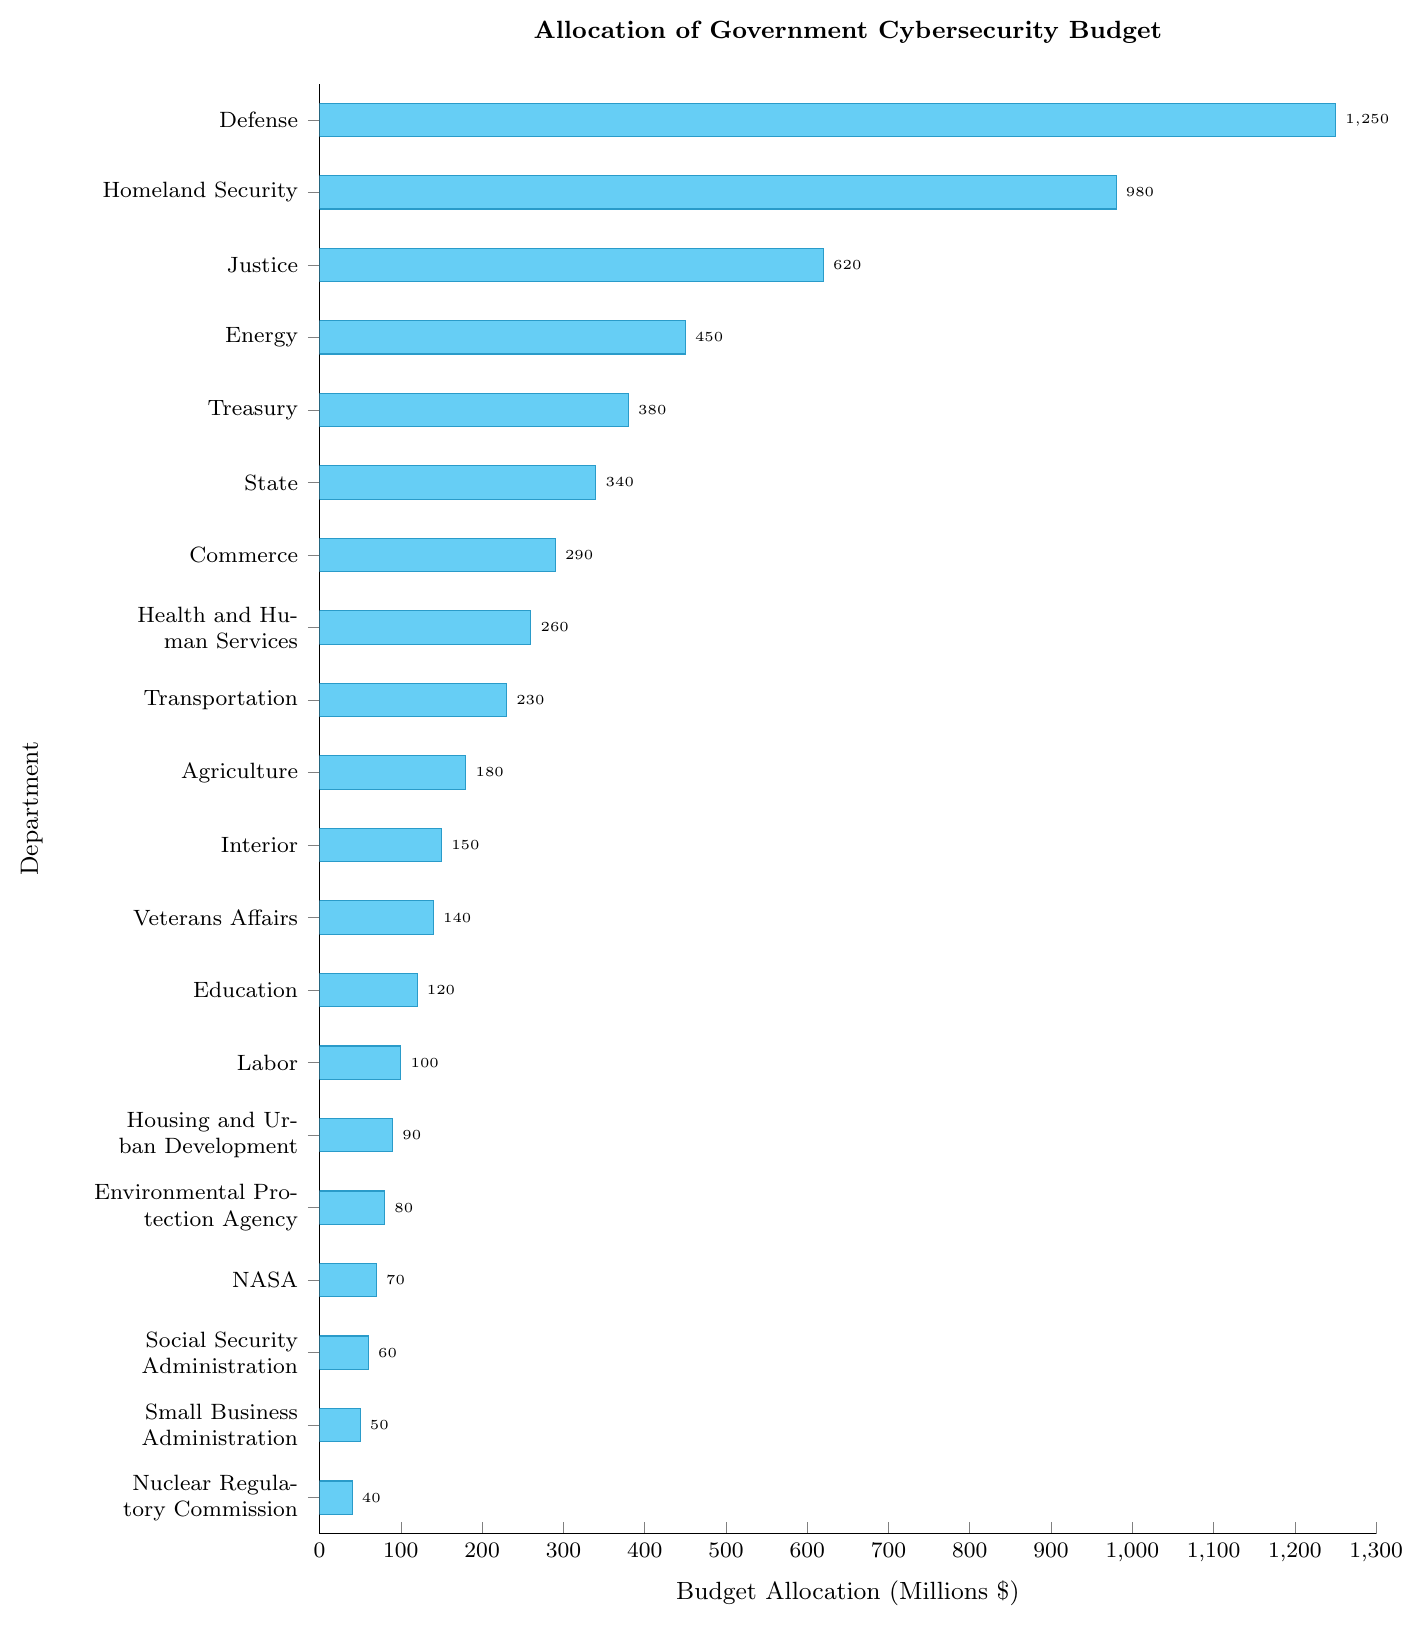Which department receives the highest cybersecurity budget? The bar representing the "Defense" department is the longest, indicating it has the highest budget allocation
Answer: Defense What is the budget allocation for the Department of Energy? The figure shows a bar next to the "Energy" label with a marker at the corresponding value on the x-axis, indicating the allocation
Answer: 450 million dollars How does the budget for Homeland Security compare to that of the Department of Defense? Both bars are visible, and the Homeland Security bar is shorter than the Defense bar, indicating a smaller budget
Answer: Homeland Security has a smaller budget What is the sum of the budget allocations for the Department of Justice and the Treasury? The Justice department has a bar of 620 million dollars and the Treasury has 380 million dollars; adding them together gives 620 + 380
Answer: 1000 million dollars Which departments have a budget allocation greater than 500 million dollars? Observing the figure, the departments with bars extending past the 500-million dollar mark are Defense, Homeland Security, and Justice
Answer: Defense, Homeland Security, Justice What is the difference in budget allocation between the Department of Veterans Affairs and the Department of Education? The Veterans Affairs bar is at 140 million dollars, and the Education department's bar is at 120 million dollars; subtracting 120 from 140 gives 140 - 120
Answer: 20 million dollars What is the average budget allocation for the departments of Commerce, Health and Human Services, and Transportation? The allocations are 290, 260, and 230 million dollars respectively. Summing these gives 290 + 260 + 230 = 780, and dividing by the number of departments (3) gives 780/3
Answer: 260 million dollars Which of the smaller departments (less than 100 million dollars) has the smallest allocation? Observing the bars for the smaller allocations, the bar for the Nuclear Regulatory Commission at 40 million dollars is the smallest
Answer: Nuclear Regulatory Commission Among the Departments of Agriculture, Interior, and Veterans Affairs, which one has the highest budget? Comparing the bars, Agriculture is at 180, Interior at 150, and Veterans Affairs at 140 million dollars. The tallest bar is for Agriculture
Answer: Agriculture By how much does the Department of Defense's budget exceed the combined budget of the State and Treasury departments? Defense's budget is 1250 million dollars, State is 340, and Treasury is 380; their combined budget is 340 + 380 = 720. The difference is 1250 - 720
Answer: 530 million dollars 